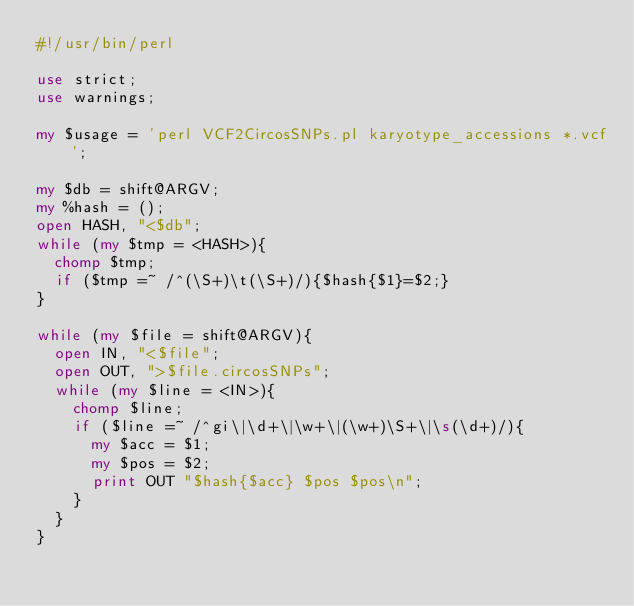Convert code to text. <code><loc_0><loc_0><loc_500><loc_500><_Perl_>#!/usr/bin/perl

use strict;
use warnings;

my $usage = 'perl VCF2CircosSNPs.pl karyotype_accessions *.vcf';

my $db = shift@ARGV;
my %hash = ();
open HASH, "<$db";
while (my $tmp = <HASH>){
	chomp $tmp;
	if ($tmp =~ /^(\S+)\t(\S+)/){$hash{$1}=$2;}
}

while (my $file = shift@ARGV){
	open IN, "<$file";
	open OUT, ">$file.circosSNPs";
	while (my $line = <IN>){
		chomp $line;
		if ($line =~ /^gi\|\d+\|\w+\|(\w+)\S+\|\s(\d+)/){
			my $acc = $1;
			my $pos = $2;
			print OUT "$hash{$acc} $pos $pos\n";
		}
	}
}</code> 